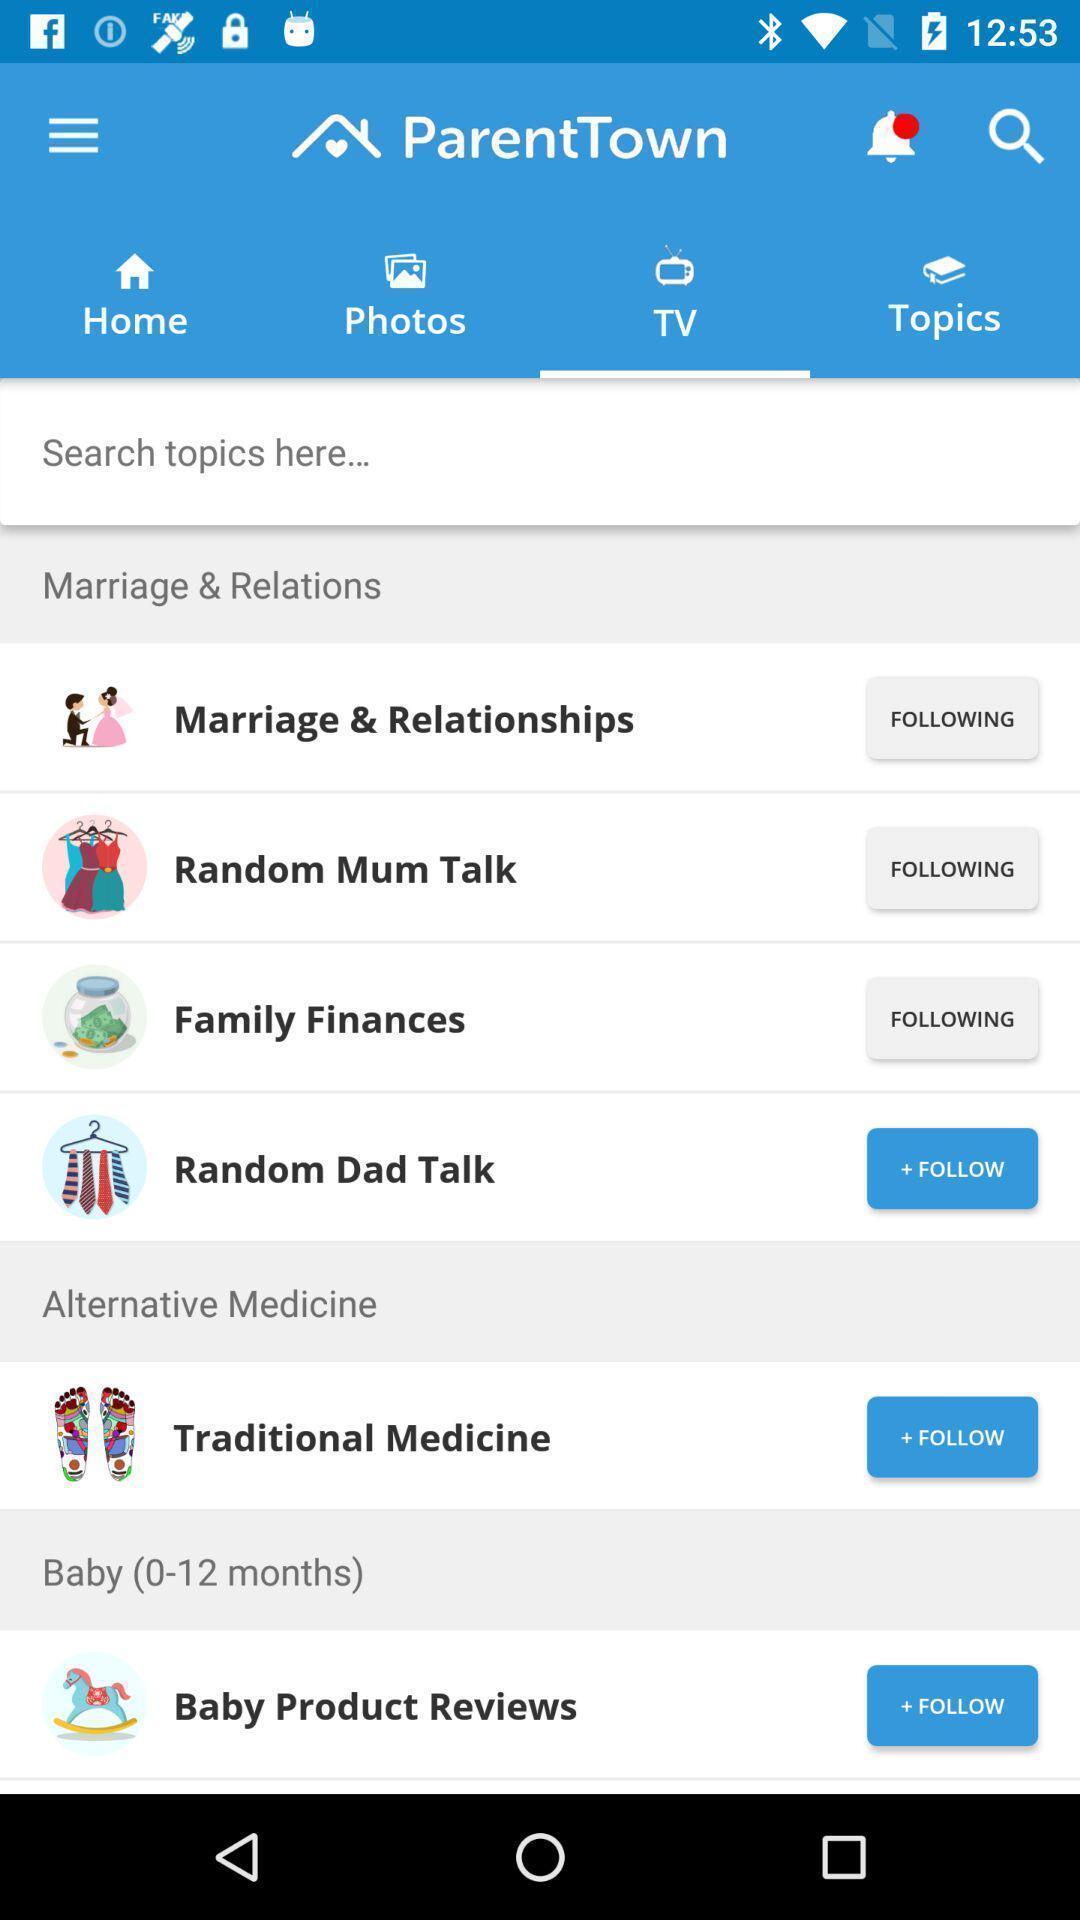What can you discern from this picture? Search of topics bar in parenting app. 